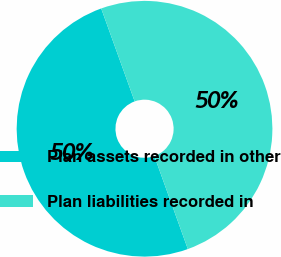<chart> <loc_0><loc_0><loc_500><loc_500><pie_chart><fcel>Plan assets recorded in other<fcel>Plan liabilities recorded in<nl><fcel>50.0%<fcel>50.0%<nl></chart> 